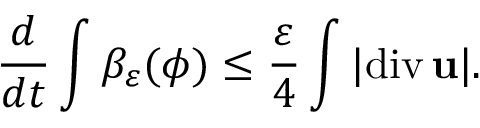Convert formula to latex. <formula><loc_0><loc_0><loc_500><loc_500>\frac { d } { d t } \int \beta _ { \varepsilon } ( \phi ) \leq \frac { \varepsilon } { 4 } \int | d i v \, { u } | .</formula> 